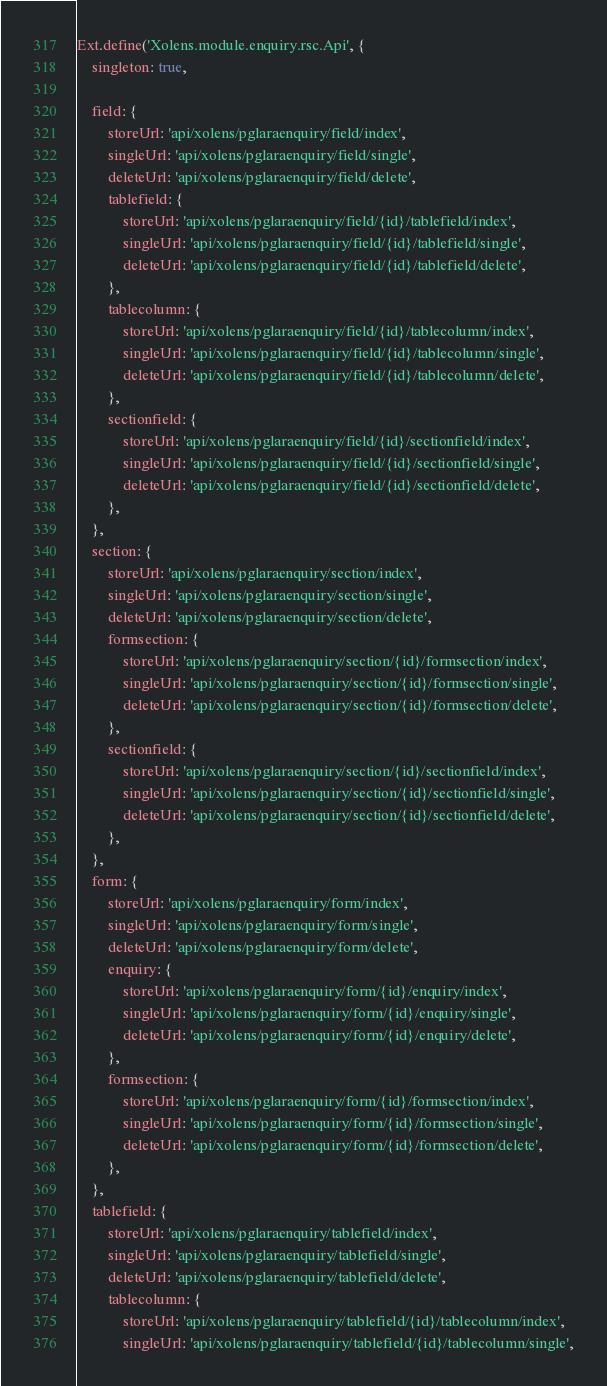Convert code to text. <code><loc_0><loc_0><loc_500><loc_500><_JavaScript_>Ext.define('Xolens.module.enquiry.rsc.Api', {
    singleton: true,

    field: {
        storeUrl: 'api/xolens/pglaraenquiry/field/index',
        singleUrl: 'api/xolens/pglaraenquiry/field/single',
        deleteUrl: 'api/xolens/pglaraenquiry/field/delete',
        tablefield: {
            storeUrl: 'api/xolens/pglaraenquiry/field/{id}/tablefield/index',
            singleUrl: 'api/xolens/pglaraenquiry/field/{id}/tablefield/single',
            deleteUrl: 'api/xolens/pglaraenquiry/field/{id}/tablefield/delete',
        },
        tablecolumn: {
            storeUrl: 'api/xolens/pglaraenquiry/field/{id}/tablecolumn/index',
            singleUrl: 'api/xolens/pglaraenquiry/field/{id}/tablecolumn/single',
            deleteUrl: 'api/xolens/pglaraenquiry/field/{id}/tablecolumn/delete',
        },
        sectionfield: {
            storeUrl: 'api/xolens/pglaraenquiry/field/{id}/sectionfield/index',
            singleUrl: 'api/xolens/pglaraenquiry/field/{id}/sectionfield/single',
            deleteUrl: 'api/xolens/pglaraenquiry/field/{id}/sectionfield/delete',
        },
    },
    section: {
        storeUrl: 'api/xolens/pglaraenquiry/section/index',
        singleUrl: 'api/xolens/pglaraenquiry/section/single',
        deleteUrl: 'api/xolens/pglaraenquiry/section/delete',
        formsection: {
            storeUrl: 'api/xolens/pglaraenquiry/section/{id}/formsection/index',
            singleUrl: 'api/xolens/pglaraenquiry/section/{id}/formsection/single',
            deleteUrl: 'api/xolens/pglaraenquiry/section/{id}/formsection/delete',
        },
        sectionfield: {
            storeUrl: 'api/xolens/pglaraenquiry/section/{id}/sectionfield/index',
            singleUrl: 'api/xolens/pglaraenquiry/section/{id}/sectionfield/single',
            deleteUrl: 'api/xolens/pglaraenquiry/section/{id}/sectionfield/delete',
        },
    },
    form: {
        storeUrl: 'api/xolens/pglaraenquiry/form/index',
        singleUrl: 'api/xolens/pglaraenquiry/form/single',
        deleteUrl: 'api/xolens/pglaraenquiry/form/delete',
        enquiry: {
            storeUrl: 'api/xolens/pglaraenquiry/form/{id}/enquiry/index',
            singleUrl: 'api/xolens/pglaraenquiry/form/{id}/enquiry/single',
            deleteUrl: 'api/xolens/pglaraenquiry/form/{id}/enquiry/delete',
        },
        formsection: {
            storeUrl: 'api/xolens/pglaraenquiry/form/{id}/formsection/index',
            singleUrl: 'api/xolens/pglaraenquiry/form/{id}/formsection/single',
            deleteUrl: 'api/xolens/pglaraenquiry/form/{id}/formsection/delete',
        },
    },
    tablefield: {
        storeUrl: 'api/xolens/pglaraenquiry/tablefield/index',
        singleUrl: 'api/xolens/pglaraenquiry/tablefield/single',
        deleteUrl: 'api/xolens/pglaraenquiry/tablefield/delete',
        tablecolumn: {
            storeUrl: 'api/xolens/pglaraenquiry/tablefield/{id}/tablecolumn/index',
            singleUrl: 'api/xolens/pglaraenquiry/tablefield/{id}/tablecolumn/single',</code> 